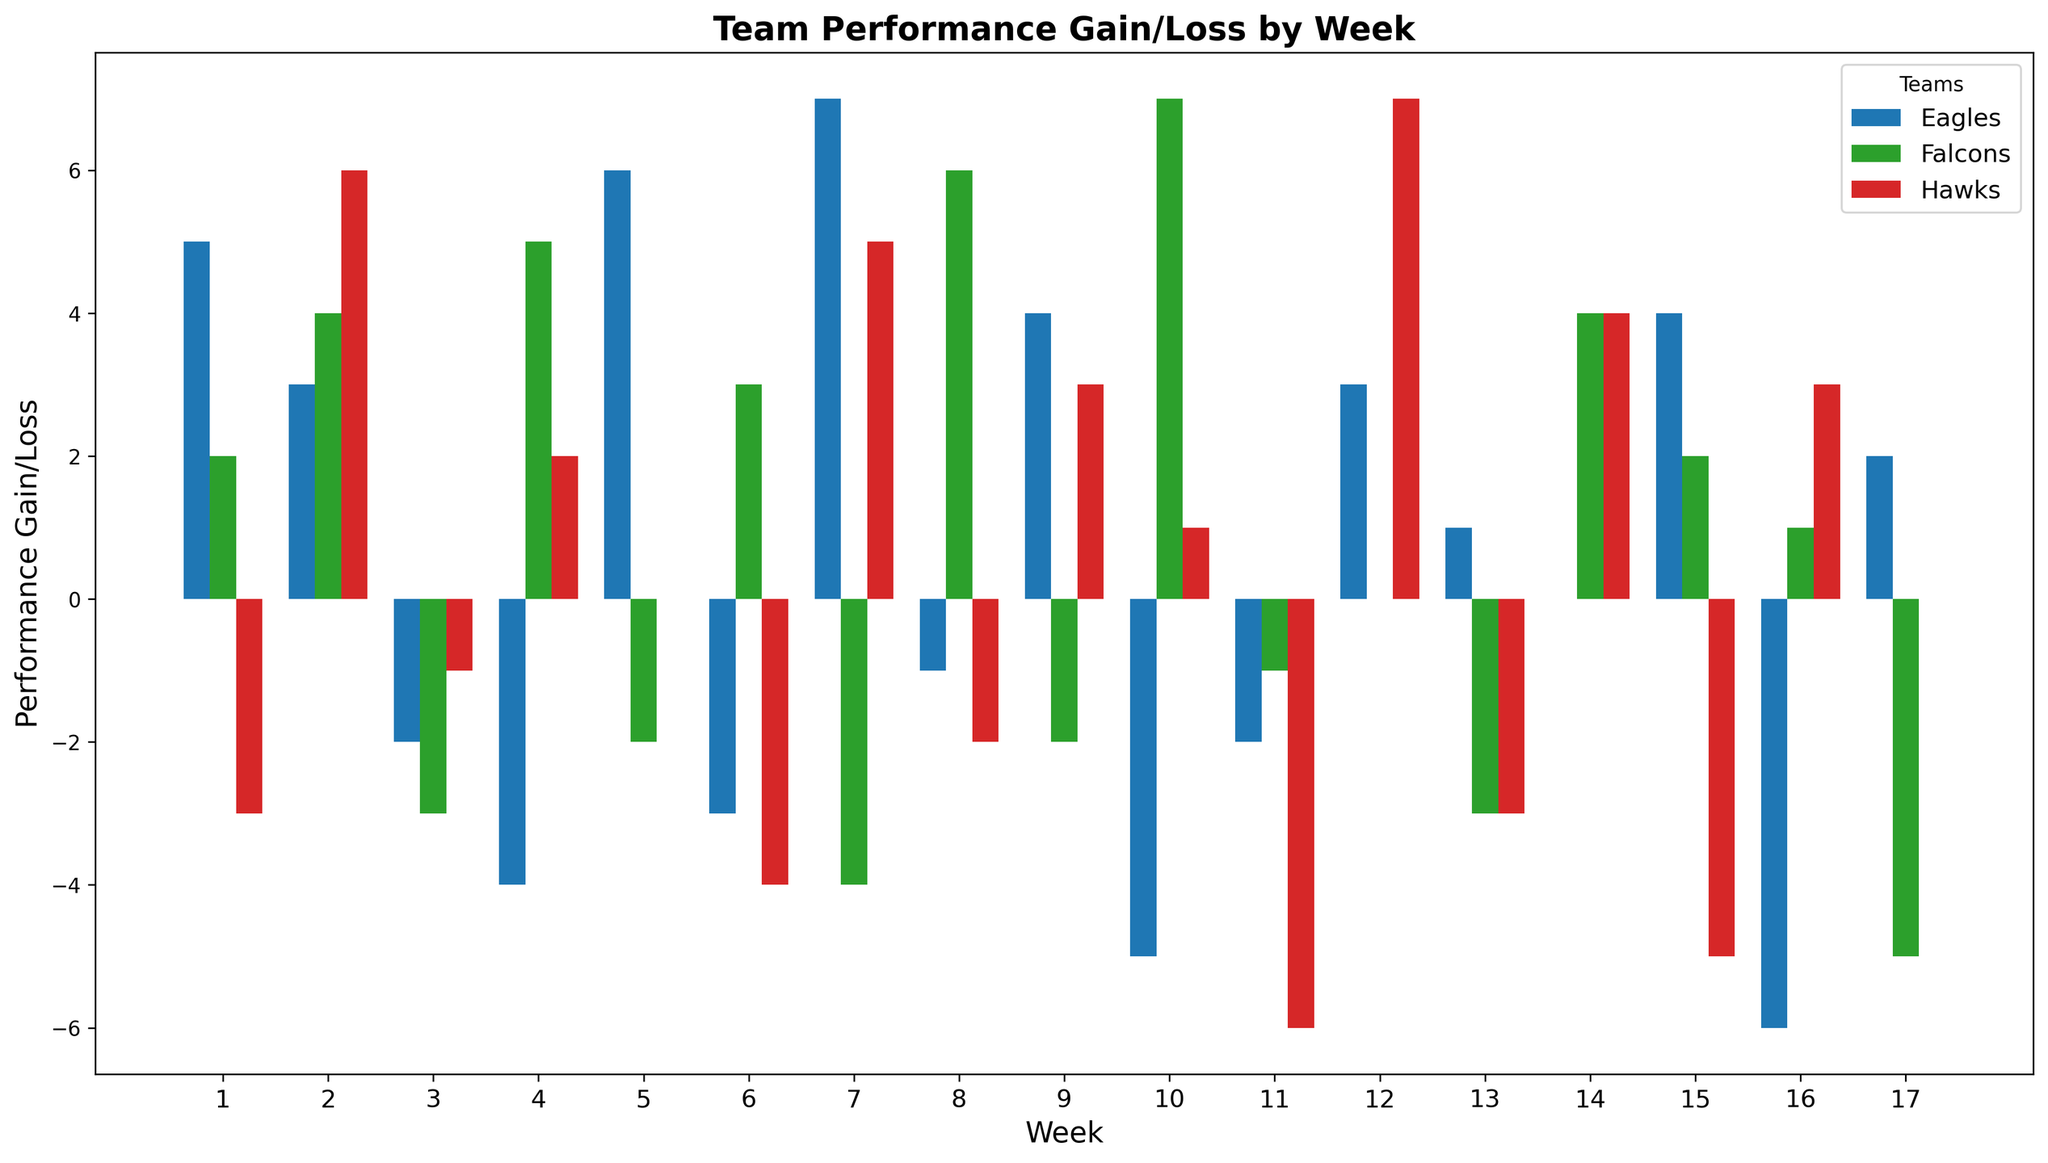Which team had the highest performance gain in any week? The highest bar among all weeks and all teams represents the largest performance gain. For the Falcons in week 10, the performance gain is 7, which is the highest value.
Answer: Falcons Which team had the most weeks with negative performance losses? Count the number of weeks with negative bars for each team. The Eagles had the most weeks with negative performance losses, with 7 weeks showing a loss.
Answer: Eagles During which week did the Hawks experience their largest performance loss? Look for the largest negative bar for the Hawks. This occurs in week 11 where the value is -6.
Answer: Week 11 By how many points did the Eagles' performance gain in week 7 exceed the Falcons' gain in the same week? The Eagles gained 7 points in week 7 and the Falcons lost 4 points in the same week, so the difference is 7 - (-4) = 11 points.
Answer: 11 points What is the average performance gain/loss for the Falcons across all weeks? Add all the performance gain/loss values for the Falcons and divide by the number of weeks: (2+4-3+5-2+3-4+6-2+7-1+0-3+4+2+1-5)/17 = 18/17 ≈ 1.06
Answer: 1.06 Which team showed the most consistent performance gains and losses? To determine consistency, look at the variability in performance gains and losses. The Hawks have the smallest range of performance values, not exceeding +/-7, suggesting more consistency compared to the Eagles and Falcons.
Answer: Hawks Between the Eagles and Hawks, which team had more weeks with zero performance change? Count the number of bars with zero height for both teams. The Eagles had one week with zero performance change (week 14), and the Hawks also had one week with zero performance change (week 5).
Answer: Tie In which week did all teams show a positive performance gain? Identify the week where all bars for the three teams are above the x-axis. In no week did all teams show a positive performance gain.
Answer: None How many times did the Eagles and Falcons both experience negative performance losses in the same week? Count the weeks where both teams have bars below the x-axis. This occurs in weeks 3, 7, and 10, so there are 3 times.
Answer: 3 Which team had the least number of weeks with negative performance losses? Count the weeks with negative values for each team. The Hawks had the least number with 5 weeks of negative performance losses.
Answer: Hawks 